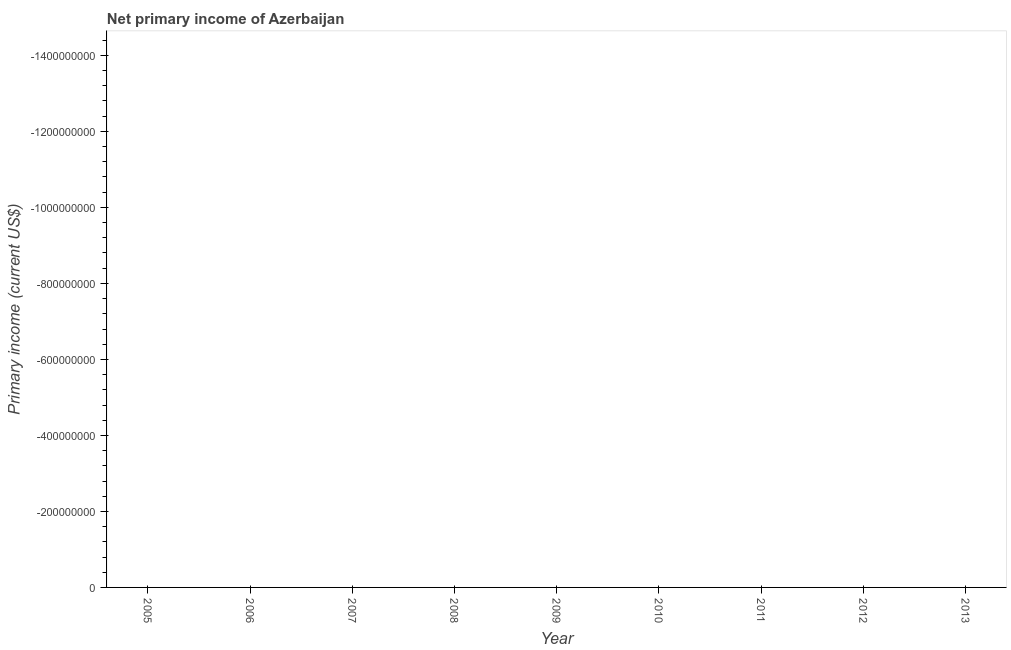Across all years, what is the minimum amount of primary income?
Make the answer very short. 0. What is the median amount of primary income?
Ensure brevity in your answer.  0. Does the graph contain any zero values?
Provide a short and direct response. Yes. What is the title of the graph?
Your answer should be compact. Net primary income of Azerbaijan. What is the label or title of the Y-axis?
Make the answer very short. Primary income (current US$). What is the Primary income (current US$) of 2005?
Your response must be concise. 0. What is the Primary income (current US$) in 2007?
Keep it short and to the point. 0. What is the Primary income (current US$) in 2009?
Keep it short and to the point. 0. What is the Primary income (current US$) of 2010?
Offer a very short reply. 0. What is the Primary income (current US$) in 2011?
Make the answer very short. 0. What is the Primary income (current US$) of 2012?
Keep it short and to the point. 0. 